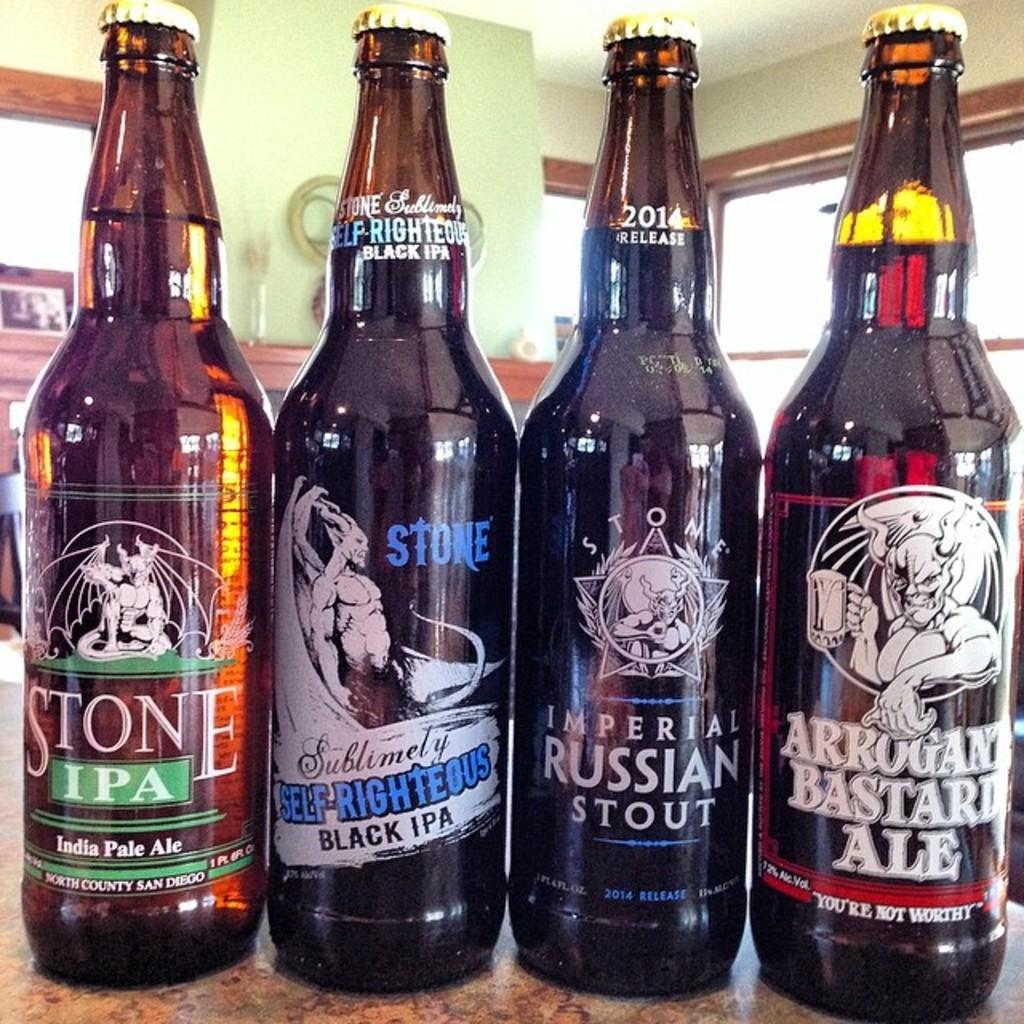<image>
Present a compact description of the photo's key features. Four bottles of beer are lined up including a bottle of Imperial Russian stout 